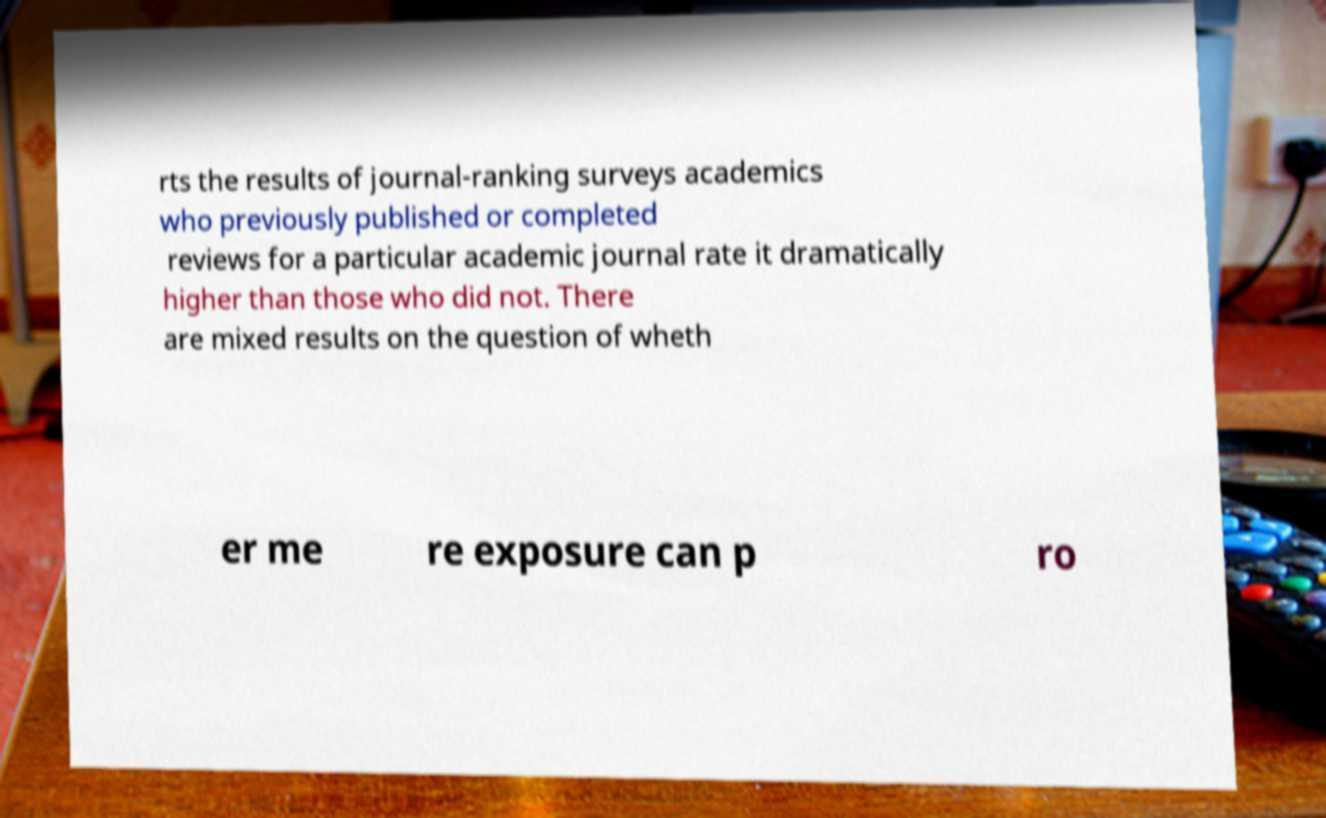I need the written content from this picture converted into text. Can you do that? rts the results of journal-ranking surveys academics who previously published or completed reviews for a particular academic journal rate it dramatically higher than those who did not. There are mixed results on the question of wheth er me re exposure can p ro 